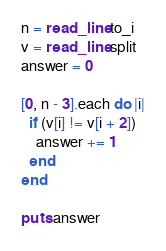Convert code to text. <code><loc_0><loc_0><loc_500><loc_500><_Crystal_>n = read_line.to_i
v = read_line.split
answer = 0

[0, n - 3].each do |i|
  if (v[i] != v[i + 2])
    answer += 1
  end
end

puts answer
</code> 